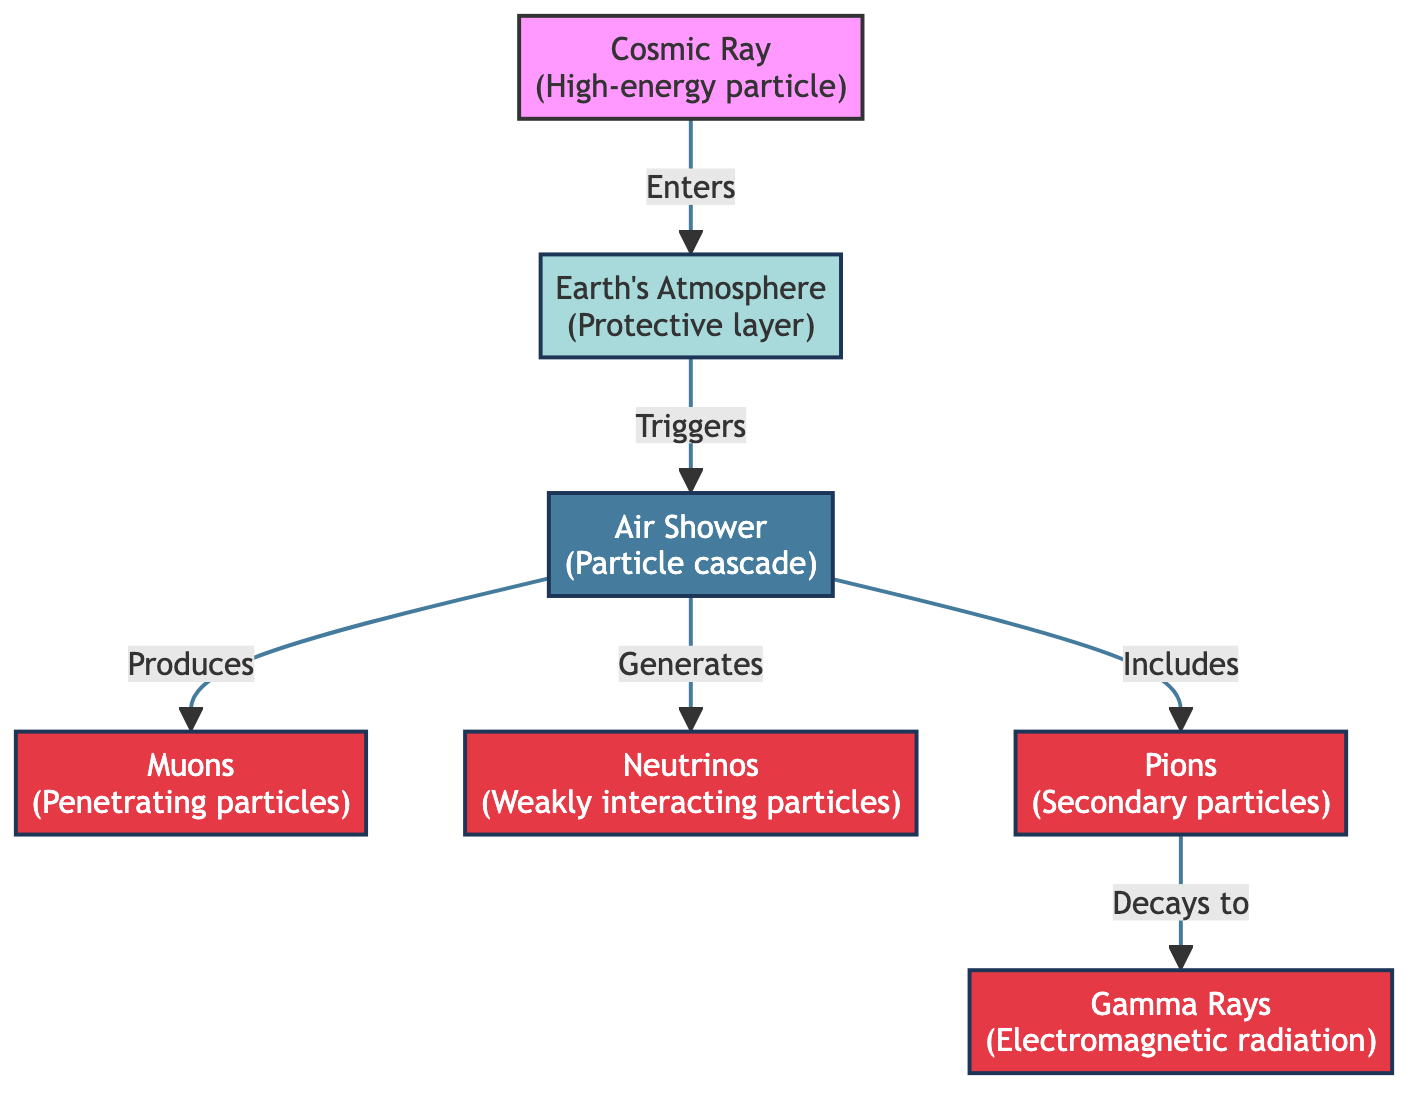What triggers the air shower? The diagram indicates that the Earth's atmosphere, after a cosmic ray enters, triggers the air shower. This is shown as a directional arrow from the atmosphere to the air shower node.
Answer: Earth's Atmosphere How many types of particles are produced in an air shower? The diagram lists four particles produced in the air shower: muons, neutrinos, pions, and gamma rays. This can be counted by identifying each particle node connected to the air shower node.
Answer: Four What do pions decay into? According to the diagram, pions decay into gamma rays, as indicated by the directional arrow from the pions node to the gamma rays node.
Answer: Gamma Rays What is the role of muons in the air shower interaction? Muons are produced during the air shower interaction, as the diagram shows a direct relationship where air shower generates muons, demonstrating their role as particles in this process.
Answer: Penetrating particles Which particle is the first to interact with the atmosphere? The diagram starts with the cosmic ray entering and then interacting with the atmosphere, making it clear that the cosmic ray is the first to initiate this interaction.
Answer: Cosmic Ray 